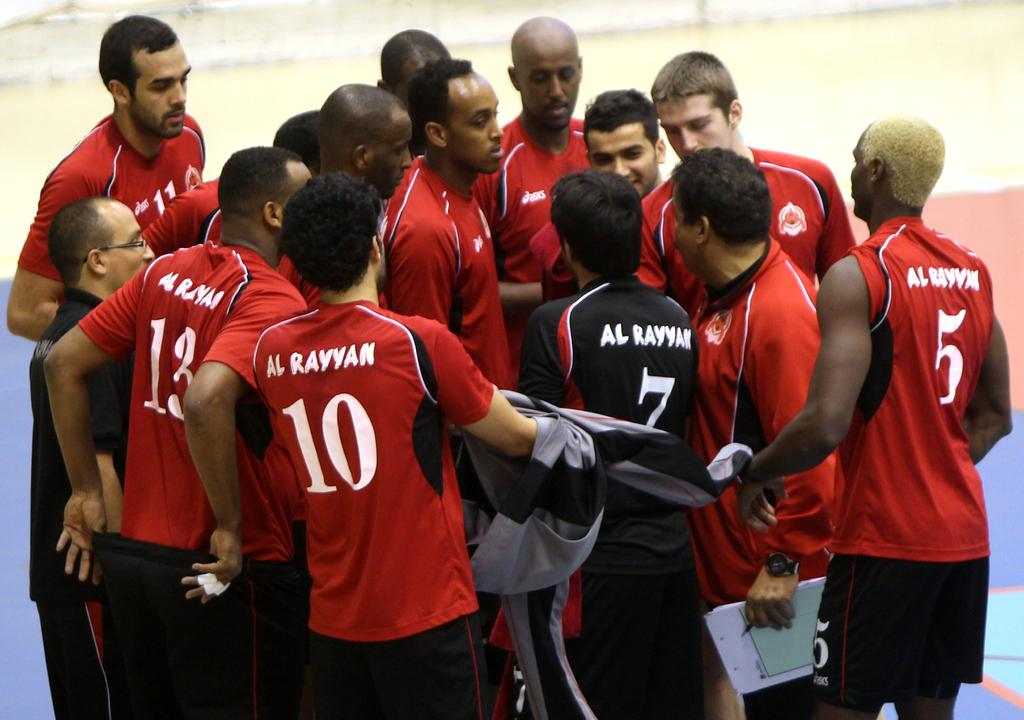<image>
Offer a succinct explanation of the picture presented. Men in red Al Rayyan jerseys gather around a man in black jersey. 